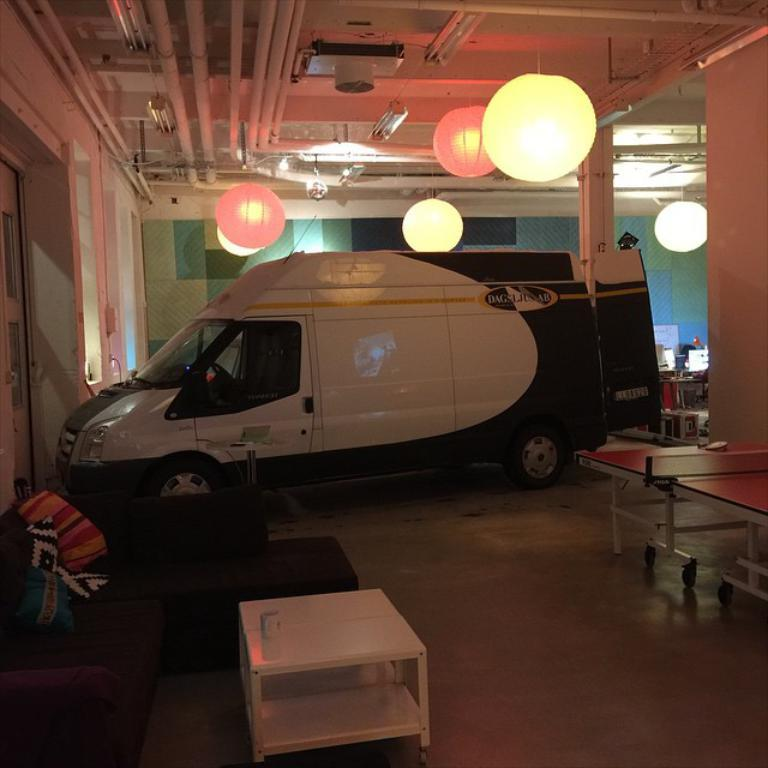What is attached to the roof in the image? Lights are attached to a roof in the image. What type of vehicle has this roof? The roof belongs to a van. What type of furniture is present in the image? There is a couch with pillows in the image. What is placed in front of the couch? In front of the couch, there is a table. What is on the table? On the table, there is a cup. What type of recreational activity is suggested by the image? There is a table tennis table in the image, suggesting table tennis as a possible activity. Can you tell me how many giraffes are playing table tennis in the image? There are no giraffes present in the image, and therefore no such activity can be observed. What type of crime is being committed in the image? There is no crime being committed in the image; it features a van with lights, a couch, a table, a cup, and a table tennis table. 